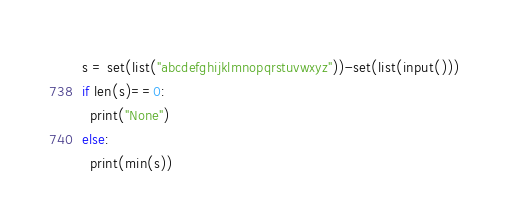Convert code to text. <code><loc_0><loc_0><loc_500><loc_500><_Python_>s = set(list("abcdefghijklmnopqrstuvwxyz"))-set(list(input()))
if len(s)==0:
  print("None")
else:
  print(min(s))
</code> 